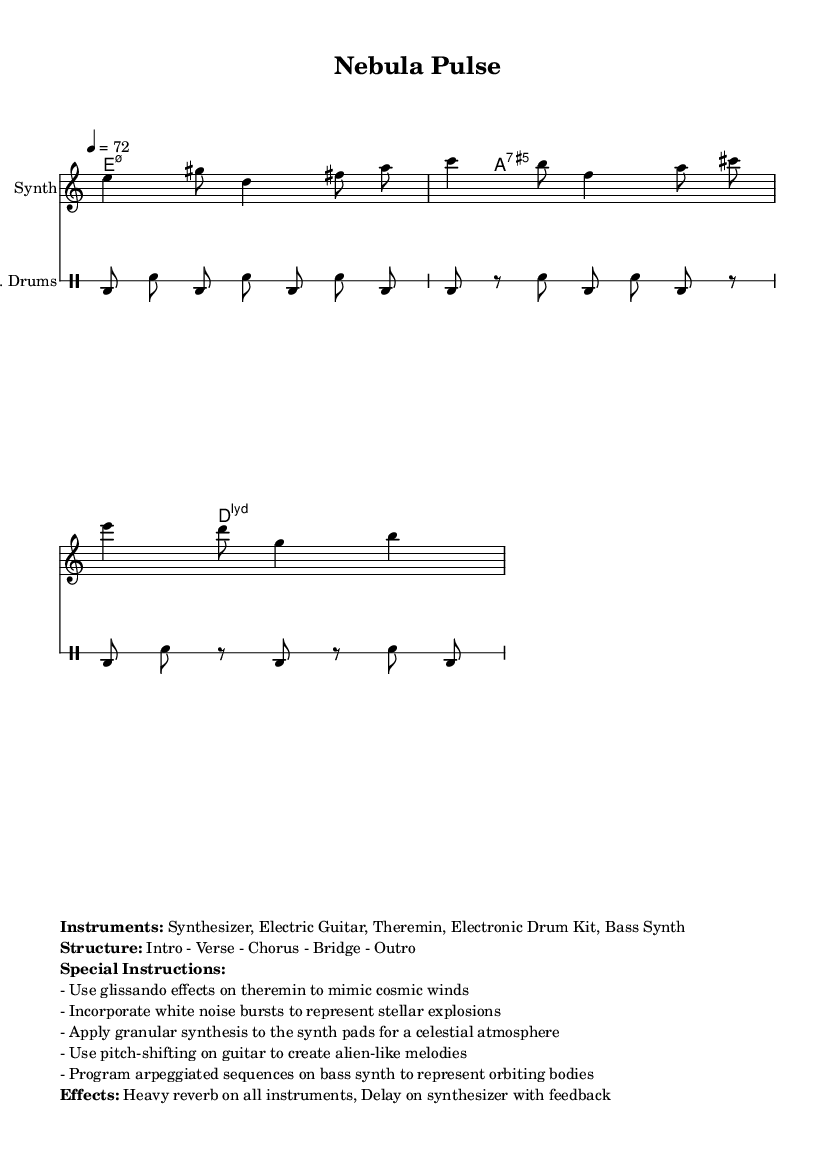What is the time signature of this music? The time signature is located at the beginning of the score and is denoted by the fraction. In this case, it shows "7/8".
Answer: 7/8 What is the tempo marking for this piece? The tempo marking is found just above the staff, indicating the speed of the piece. Here, it states "4 = 72", which means there are 72 beats per minute with each beat counted as a quarter note.
Answer: 72 How many measures are in the melody section? To determine the number of measures, we count the bars in the melody notes section. There are three bars present.
Answer: 3 What is the chord progression in the harmonies? The chord progression is indicated in the chord mode section, which lists three chords: e minor 7.5, A 7.5, and D major 7.11. This indicates the harmonic structure of the piece.
Answer: E minor 7.5, A 7.5, D major 7.11 What is the main instrumentation used in the piece? The instrumentation is listed in the markup section under "Instruments:", where it specifies the following: Synthesizer, Electric Guitar, Theremin, Electronic Drum Kit, and Bass Synth.
Answer: Synthesizer, Electric Guitar, Theremin, Electronic Drum Kit, Bass Synth What special instruction is given for the theremin? The special instructions specify that the theremin should use glissando effects to mimic cosmic winds. This indicates a particular performance technique intended to contribute to the overall sound.
Answer: Use glissando effects to mimic cosmic winds What type of synthesis is suggested for the synth pads? The instructions indicate that granular synthesis should be applied to the synth pads, suggesting a technique that enhances the celestial atmosphere of the piece.
Answer: Granular synthesis 